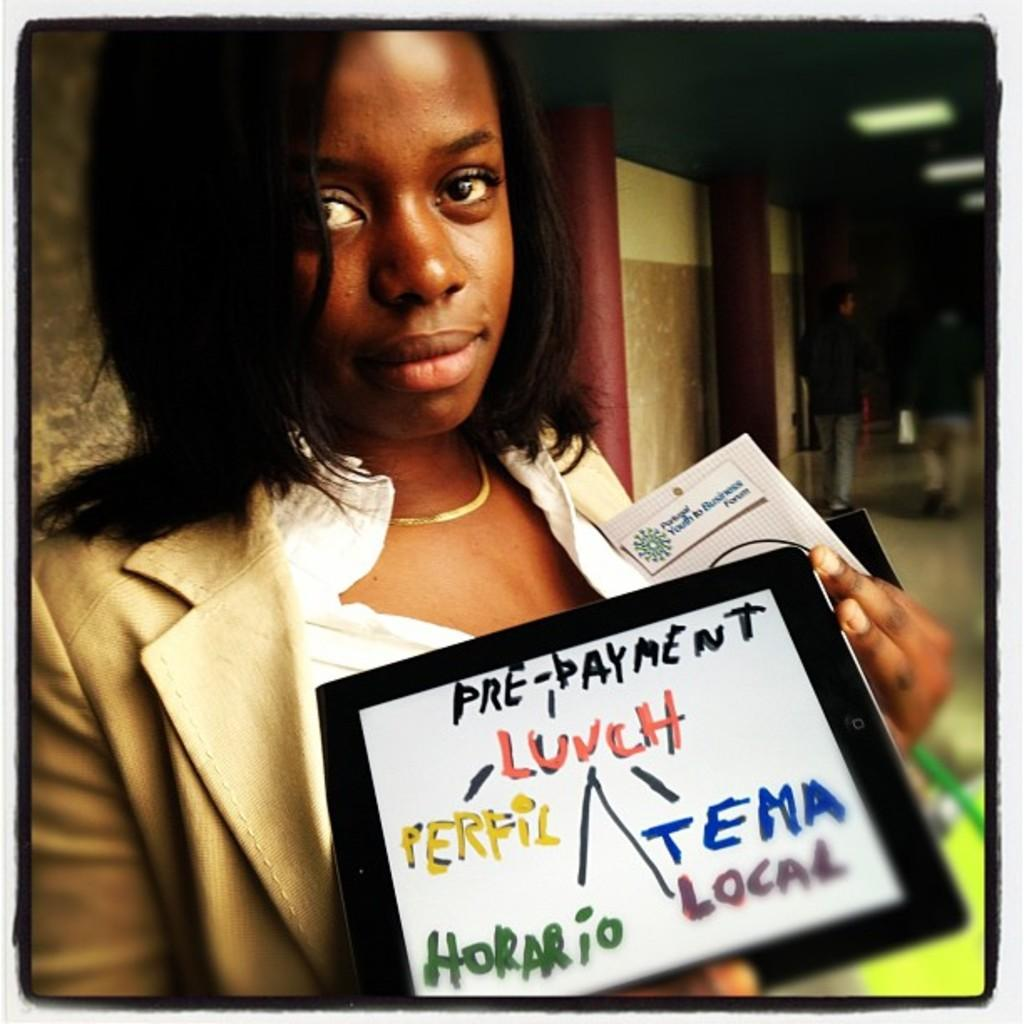What is the woman in the image doing? The woman is standing in the image and holding a placard with text. What can be seen in the background of the image? There are people walking in the background of the image. What is present on the ceiling in the image? There are lights on the ceiling in the image. What type of eggnog is being served in the lunchroom in the image? There is no mention of a lunchroom or eggnog in the image; it features a woman holding a placard and people walking in the background. 